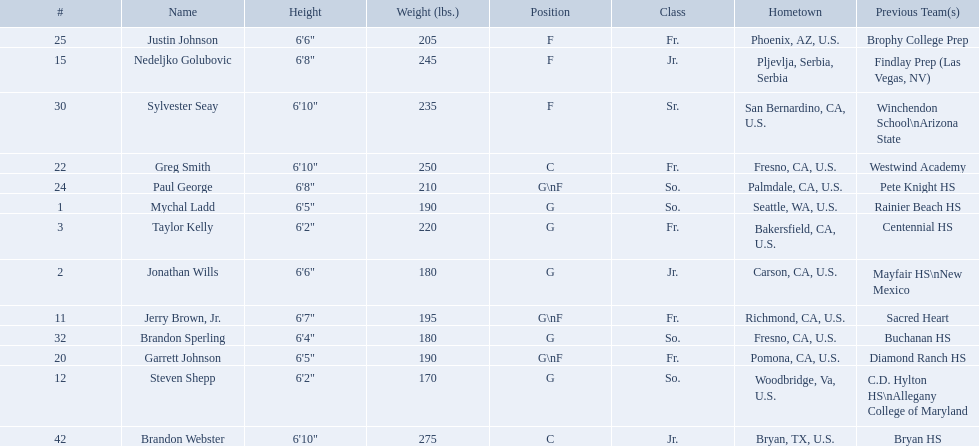Which positions are so.? G, G, G\nF, G. Which weights are g 190, 170, 180. What height is under 6 3' 6'2". What is the name Steven Shepp. What class was each team member in for the 2009-10 fresno state bulldogs? So., Jr., Fr., Fr., So., Jr., Fr., Fr., So., Fr., Sr., So., Jr. Which of these was outside of the us? Jr. Who was the player? Nedeljko Golubovic. Parse the full table. {'header': ['#', 'Name', 'Height', 'Weight (lbs.)', 'Position', 'Class', 'Hometown', 'Previous Team(s)'], 'rows': [['25', 'Justin Johnson', '6\'6"', '205', 'F', 'Fr.', 'Phoenix, AZ, U.S.', 'Brophy College Prep'], ['15', 'Nedeljko Golubovic', '6\'8"', '245', 'F', 'Jr.', 'Pljevlja, Serbia, Serbia', 'Findlay Prep (Las Vegas, NV)'], ['30', 'Sylvester Seay', '6\'10"', '235', 'F', 'Sr.', 'San Bernardino, CA, U.S.', 'Winchendon School\\nArizona State'], ['22', 'Greg Smith', '6\'10"', '250', 'C', 'Fr.', 'Fresno, CA, U.S.', 'Westwind Academy'], ['24', 'Paul George', '6\'8"', '210', 'G\\nF', 'So.', 'Palmdale, CA, U.S.', 'Pete Knight HS'], ['1', 'Mychal Ladd', '6\'5"', '190', 'G', 'So.', 'Seattle, WA, U.S.', 'Rainier Beach HS'], ['3', 'Taylor Kelly', '6\'2"', '220', 'G', 'Fr.', 'Bakersfield, CA, U.S.', 'Centennial HS'], ['2', 'Jonathan Wills', '6\'6"', '180', 'G', 'Jr.', 'Carson, CA, U.S.', 'Mayfair HS\\nNew Mexico'], ['11', 'Jerry Brown, Jr.', '6\'7"', '195', 'G\\nF', 'Fr.', 'Richmond, CA, U.S.', 'Sacred Heart'], ['32', 'Brandon Sperling', '6\'4"', '180', 'G', 'So.', 'Fresno, CA, U.S.', 'Buchanan HS'], ['20', 'Garrett Johnson', '6\'5"', '190', 'G\\nF', 'Fr.', 'Pomona, CA, U.S.', 'Diamond Ranch HS'], ['12', 'Steven Shepp', '6\'2"', '170', 'G', 'So.', 'Woodbridge, Va, U.S.', 'C.D. Hylton HS\\nAllegany College of Maryland'], ['42', 'Brandon Webster', '6\'10"', '275', 'C', 'Jr.', 'Bryan, TX, U.S.', 'Bryan HS']]} What are the names for all players? Mychal Ladd, Jonathan Wills, Taylor Kelly, Jerry Brown, Jr., Steven Shepp, Nedeljko Golubovic, Garrett Johnson, Greg Smith, Paul George, Justin Johnson, Sylvester Seay, Brandon Sperling, Brandon Webster. Which players are taller than 6'8? Nedeljko Golubovic, Greg Smith, Paul George, Sylvester Seay, Brandon Webster. How tall is paul george? 6'8". How tall is greg smith? 6'10". Of these two, which it tallest? Greg Smith. 